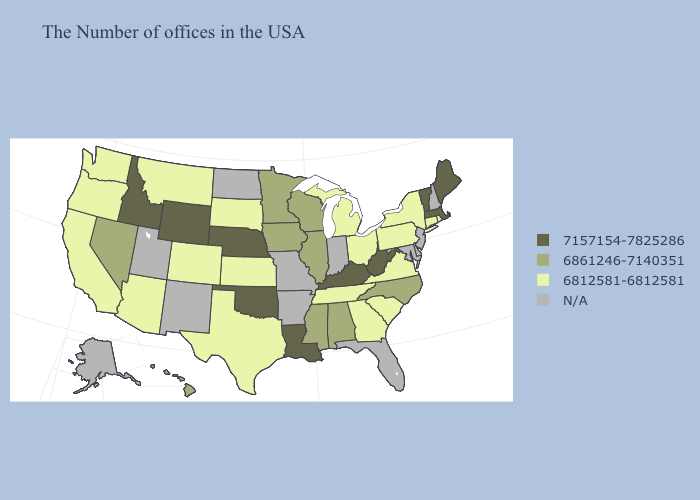What is the lowest value in states that border Oregon?
Keep it brief. 6812581-6812581. How many symbols are there in the legend?
Write a very short answer. 4. What is the highest value in the USA?
Short answer required. 7157154-7825286. What is the lowest value in the Northeast?
Concise answer only. 6812581-6812581. Does Idaho have the highest value in the West?
Be succinct. Yes. What is the highest value in the USA?
Answer briefly. 7157154-7825286. Name the states that have a value in the range 6861246-7140351?
Quick response, please. North Carolina, Alabama, Wisconsin, Illinois, Mississippi, Minnesota, Iowa, Nevada, Hawaii. What is the value of Hawaii?
Concise answer only. 6861246-7140351. Does the map have missing data?
Be succinct. Yes. What is the lowest value in the South?
Keep it brief. 6812581-6812581. What is the lowest value in states that border Pennsylvania?
Answer briefly. 6812581-6812581. Among the states that border New Mexico , does Oklahoma have the lowest value?
Concise answer only. No. Does Vermont have the lowest value in the Northeast?
Write a very short answer. No. Does Massachusetts have the highest value in the USA?
Give a very brief answer. Yes. 